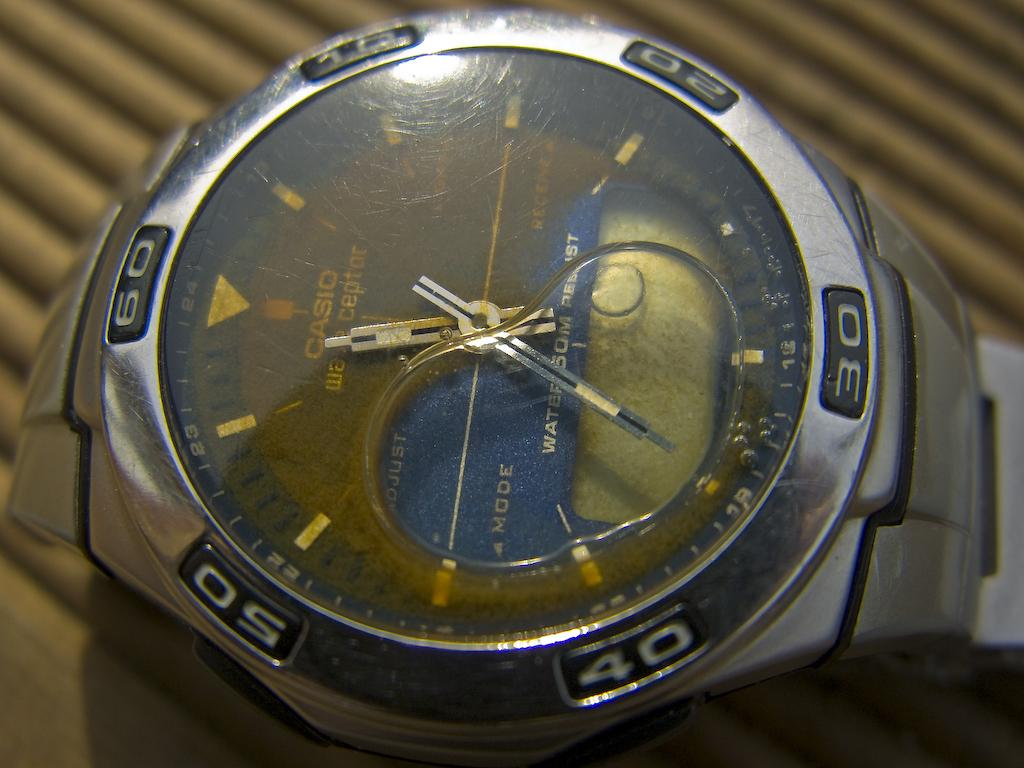<image>
Render a clear and concise summary of the photo. The water resistant Casio watch apparently was not waterproof. 